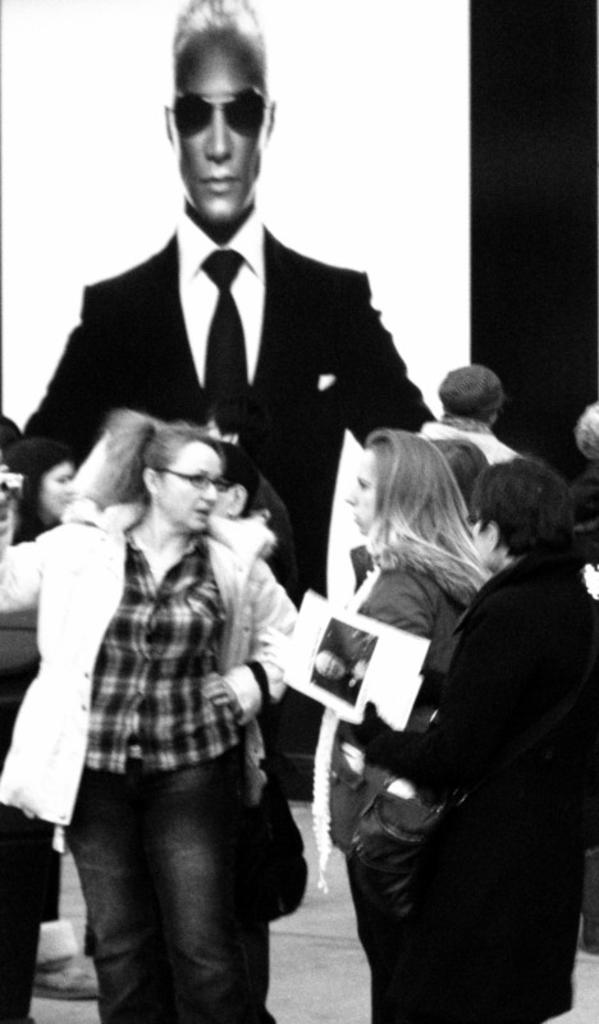In one or two sentences, can you explain what this image depicts? In the image we can see the black and white picture of the people standing and wearing clothes. Here we can see a person is wearing spectacles and other one is holding a book in hand. Here we can see the floor and the poster of the man wearing goggles and clothes. 